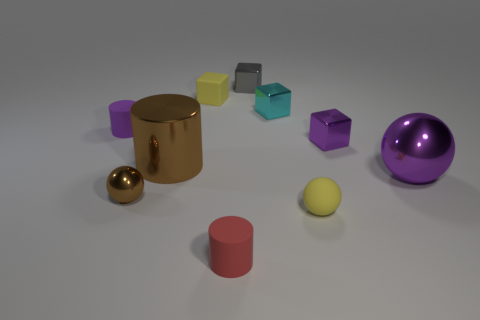Subtract all spheres. How many objects are left? 7 Add 5 small cyan metal things. How many small cyan metal things are left? 6 Add 7 brown metal things. How many brown metal things exist? 9 Subtract 0 green blocks. How many objects are left? 10 Subtract all brown matte balls. Subtract all yellow blocks. How many objects are left? 9 